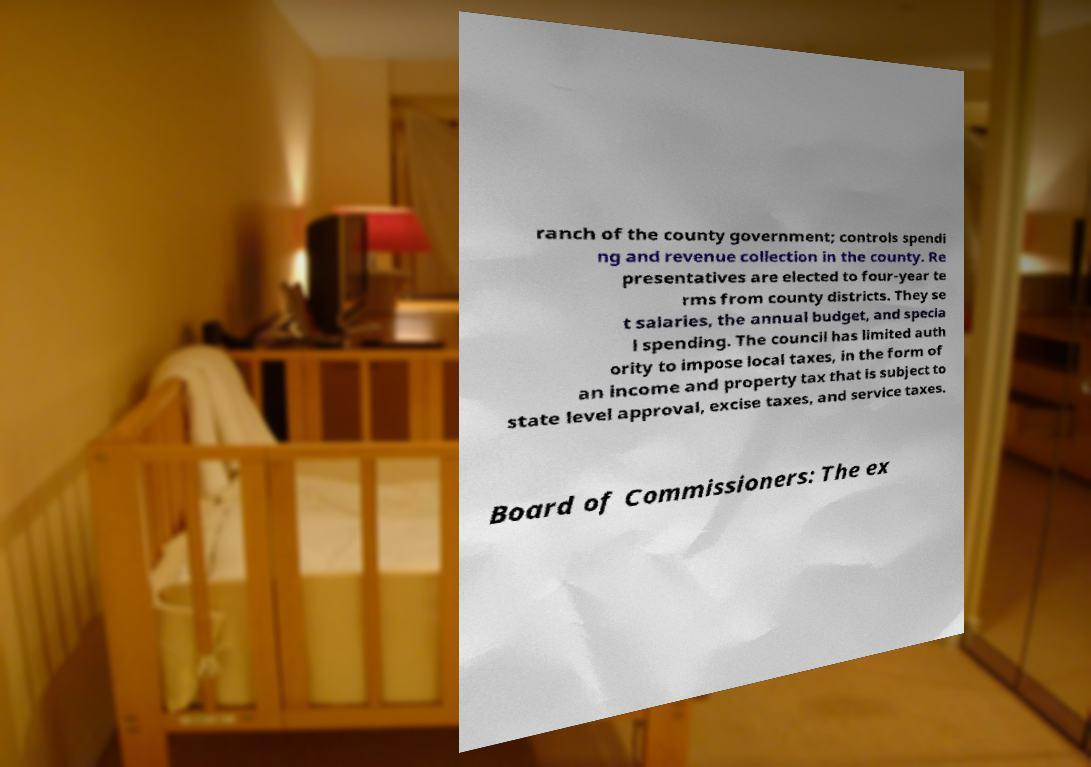For documentation purposes, I need the text within this image transcribed. Could you provide that? ranch of the county government; controls spendi ng and revenue collection in the county. Re presentatives are elected to four-year te rms from county districts. They se t salaries, the annual budget, and specia l spending. The council has limited auth ority to impose local taxes, in the form of an income and property tax that is subject to state level approval, excise taxes, and service taxes. Board of Commissioners: The ex 